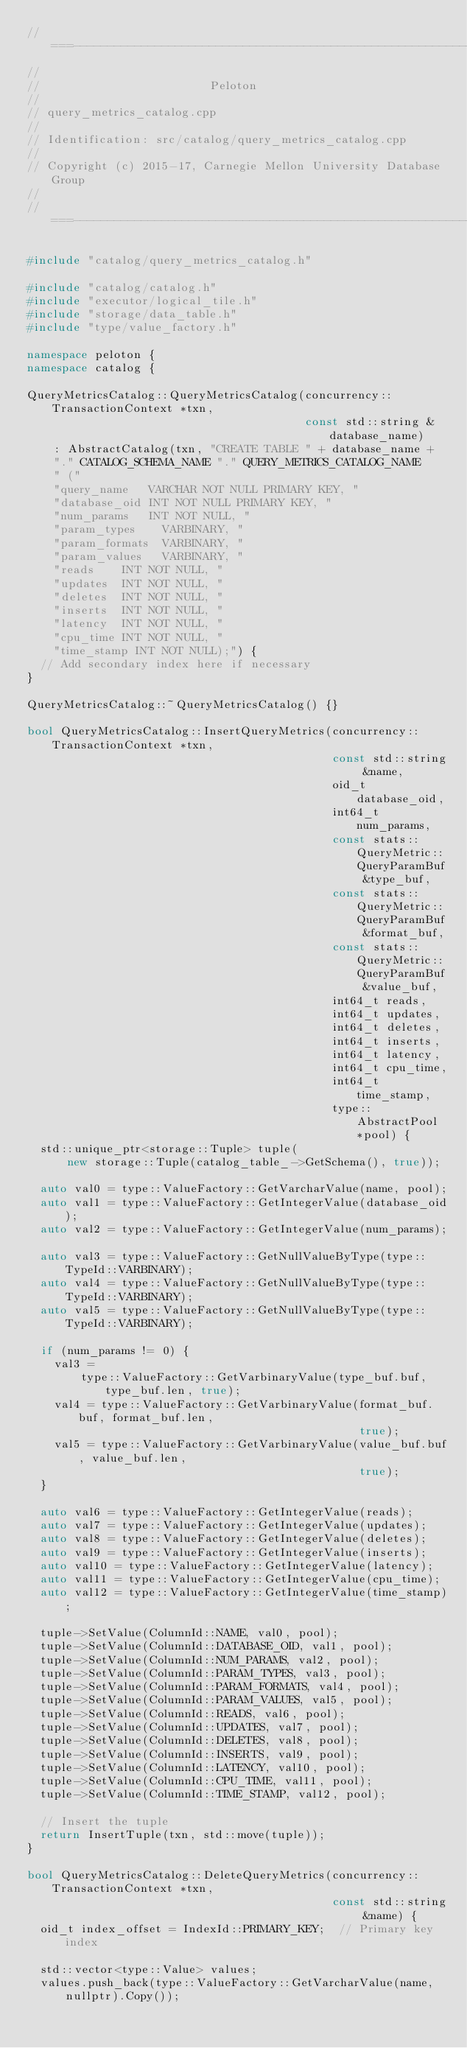Convert code to text. <code><loc_0><loc_0><loc_500><loc_500><_C++_>//===----------------------------------------------------------------------===//
//
//                         Peloton
//
// query_metrics_catalog.cpp
//
// Identification: src/catalog/query_metrics_catalog.cpp
//
// Copyright (c) 2015-17, Carnegie Mellon University Database Group
//
//===----------------------------------------------------------------------===//

#include "catalog/query_metrics_catalog.h"

#include "catalog/catalog.h"
#include "executor/logical_tile.h"
#include "storage/data_table.h"
#include "type/value_factory.h"

namespace peloton {
namespace catalog {

QueryMetricsCatalog::QueryMetricsCatalog(concurrency::TransactionContext *txn,
                                         const std::string &database_name)
    : AbstractCatalog(txn, "CREATE TABLE " + database_name +
    "." CATALOG_SCHEMA_NAME "." QUERY_METRICS_CATALOG_NAME
    " ("
    "query_name   VARCHAR NOT NULL PRIMARY KEY, "
    "database_oid INT NOT NULL PRIMARY KEY, "
    "num_params   INT NOT NULL, "
    "param_types    VARBINARY, "
    "param_formats  VARBINARY, "
    "param_values   VARBINARY, "
    "reads    INT NOT NULL, "
    "updates  INT NOT NULL, "
    "deletes  INT NOT NULL, "
    "inserts  INT NOT NULL, "
    "latency  INT NOT NULL, "
    "cpu_time INT NOT NULL, "
    "time_stamp INT NOT NULL);") {
  // Add secondary index here if necessary
}

QueryMetricsCatalog::~QueryMetricsCatalog() {}

bool QueryMetricsCatalog::InsertQueryMetrics(concurrency::TransactionContext *txn,
                                             const std::string &name,
                                             oid_t database_oid,
                                             int64_t num_params,
                                             const stats::QueryMetric::QueryParamBuf &type_buf,
                                             const stats::QueryMetric::QueryParamBuf &format_buf,
                                             const stats::QueryMetric::QueryParamBuf &value_buf,
                                             int64_t reads,
                                             int64_t updates,
                                             int64_t deletes,
                                             int64_t inserts,
                                             int64_t latency,
                                             int64_t cpu_time,
                                             int64_t time_stamp,
                                             type::AbstractPool *pool) {
  std::unique_ptr<storage::Tuple> tuple(
      new storage::Tuple(catalog_table_->GetSchema(), true));

  auto val0 = type::ValueFactory::GetVarcharValue(name, pool);
  auto val1 = type::ValueFactory::GetIntegerValue(database_oid);
  auto val2 = type::ValueFactory::GetIntegerValue(num_params);

  auto val3 = type::ValueFactory::GetNullValueByType(type::TypeId::VARBINARY);
  auto val4 = type::ValueFactory::GetNullValueByType(type::TypeId::VARBINARY);
  auto val5 = type::ValueFactory::GetNullValueByType(type::TypeId::VARBINARY);

  if (num_params != 0) {
    val3 =
        type::ValueFactory::GetVarbinaryValue(type_buf.buf, type_buf.len, true);
    val4 = type::ValueFactory::GetVarbinaryValue(format_buf.buf, format_buf.len,
                                                 true);
    val5 = type::ValueFactory::GetVarbinaryValue(value_buf.buf, value_buf.len,
                                                 true);
  }

  auto val6 = type::ValueFactory::GetIntegerValue(reads);
  auto val7 = type::ValueFactory::GetIntegerValue(updates);
  auto val8 = type::ValueFactory::GetIntegerValue(deletes);
  auto val9 = type::ValueFactory::GetIntegerValue(inserts);
  auto val10 = type::ValueFactory::GetIntegerValue(latency);
  auto val11 = type::ValueFactory::GetIntegerValue(cpu_time);
  auto val12 = type::ValueFactory::GetIntegerValue(time_stamp);

  tuple->SetValue(ColumnId::NAME, val0, pool);
  tuple->SetValue(ColumnId::DATABASE_OID, val1, pool);
  tuple->SetValue(ColumnId::NUM_PARAMS, val2, pool);
  tuple->SetValue(ColumnId::PARAM_TYPES, val3, pool);
  tuple->SetValue(ColumnId::PARAM_FORMATS, val4, pool);
  tuple->SetValue(ColumnId::PARAM_VALUES, val5, pool);
  tuple->SetValue(ColumnId::READS, val6, pool);
  tuple->SetValue(ColumnId::UPDATES, val7, pool);
  tuple->SetValue(ColumnId::DELETES, val8, pool);
  tuple->SetValue(ColumnId::INSERTS, val9, pool);
  tuple->SetValue(ColumnId::LATENCY, val10, pool);
  tuple->SetValue(ColumnId::CPU_TIME, val11, pool);
  tuple->SetValue(ColumnId::TIME_STAMP, val12, pool);

  // Insert the tuple
  return InsertTuple(txn, std::move(tuple));
}

bool QueryMetricsCatalog::DeleteQueryMetrics(concurrency::TransactionContext *txn,
                                             const std::string &name) {
  oid_t index_offset = IndexId::PRIMARY_KEY;  // Primary key index

  std::vector<type::Value> values;
  values.push_back(type::ValueFactory::GetVarcharValue(name, nullptr).Copy());</code> 